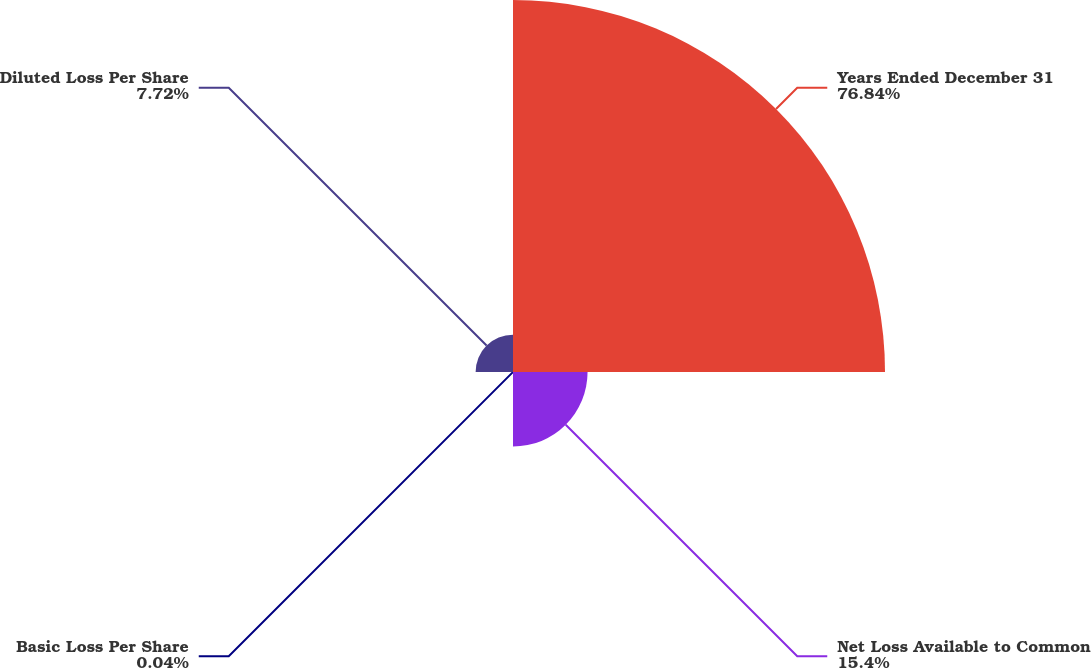Convert chart. <chart><loc_0><loc_0><loc_500><loc_500><pie_chart><fcel>Years Ended December 31<fcel>Net Loss Available to Common<fcel>Basic Loss Per Share<fcel>Diluted Loss Per Share<nl><fcel>76.84%<fcel>15.4%<fcel>0.04%<fcel>7.72%<nl></chart> 